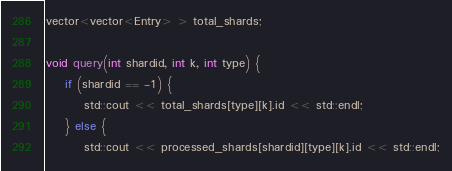<code> <loc_0><loc_0><loc_500><loc_500><_C++_>vector<vector<Entry> > total_shards;

void query(int shardid, int k, int type) {
    if (shardid == -1) {
        std::cout << total_shards[type][k].id << std::endl;
    } else {
        std::cout << processed_shards[shardid][type][k].id << std::endl;</code> 